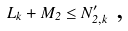<formula> <loc_0><loc_0><loc_500><loc_500>L _ { k } + M _ { 2 } \leq N _ { 2 , k } ^ { \prime } \text { ,}</formula> 